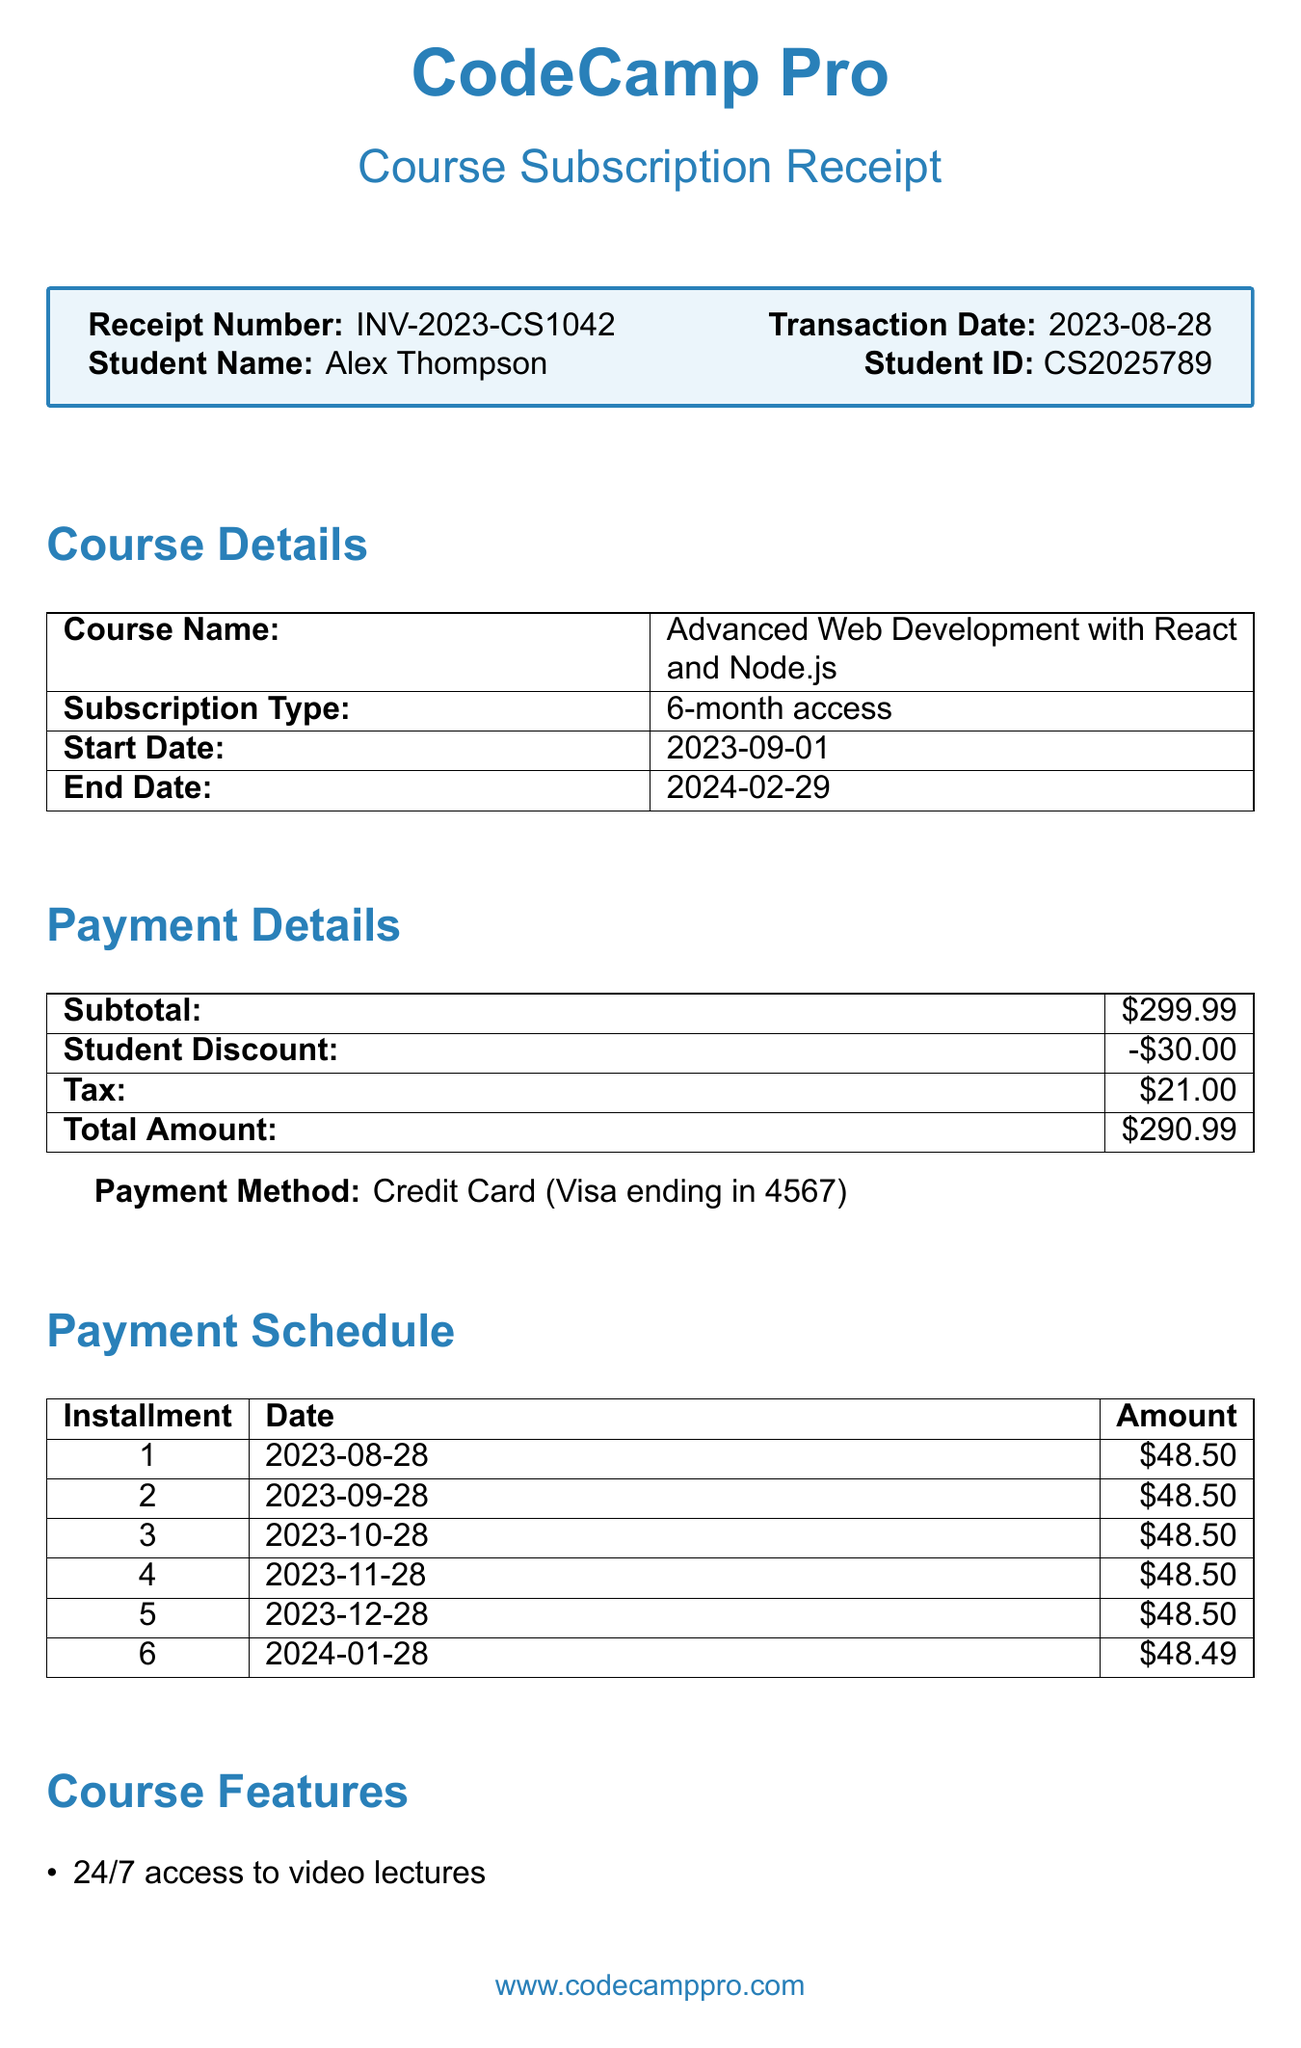What is the receipt number? The receipt number is a unique identifier for the transaction in the document.
Answer: INV-2023-CS1042 What is the student's name? The student's name is mentioned at the beginning of the document.
Answer: Alex Thompson What is the course name? The course name specifies the title of the course the student has subscribed to.
Answer: Advanced Web Development with React and Node.js What is the total amount paid? The total amount is the final cost after applying discounts and tax.
Answer: $290.99 What is the start date of the course? The start date indicates when the subscription for the course begins.
Answer: 2023-09-01 How many installments are there for the payment? The document lists the payment schedule, showing how many installments are to be made.
Answer: 6 What type of discount was applied? The discount type shows the reason for the discount offered to the student.
Answer: Student discount What is the refund policy? The refund policy states the time frame within which a refund can be requested.
Answer: 14-day money-back guarantee What feature allows interaction with instructors? The features include options that enhance the learning experience, specifically mentioning instructor interaction.
Answer: Live coding sessions with instructors What is the support email? The support email provides a direct contact for assistance regarding the course.
Answer: support@codecamppro.com 